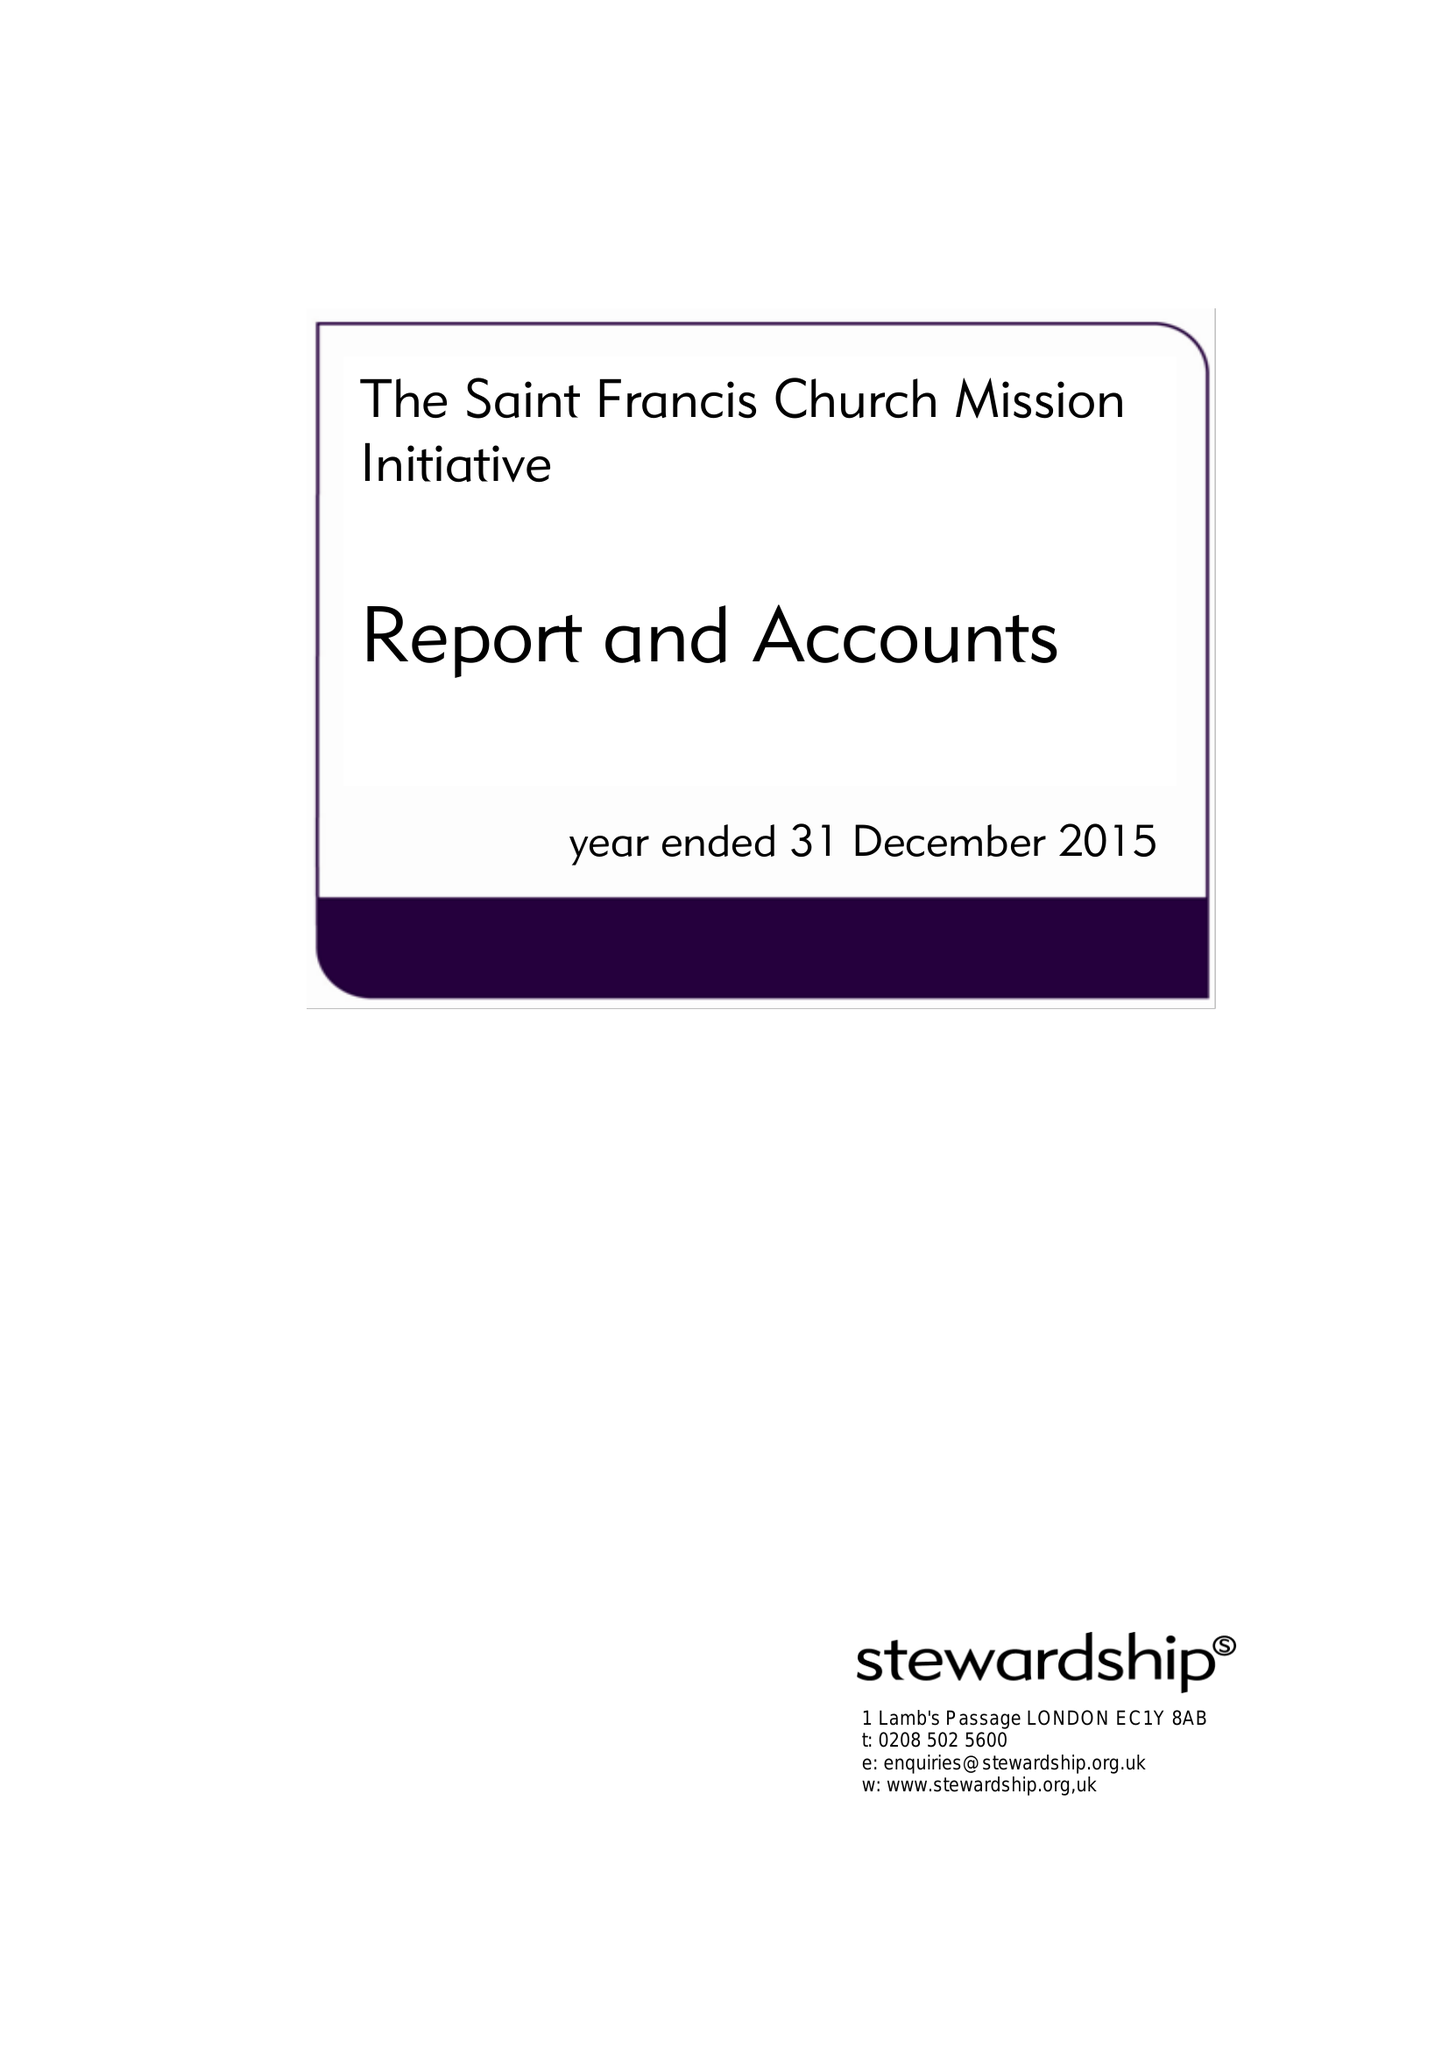What is the value for the address__postcode?
Answer the question using a single word or phrase. W10 5EL 